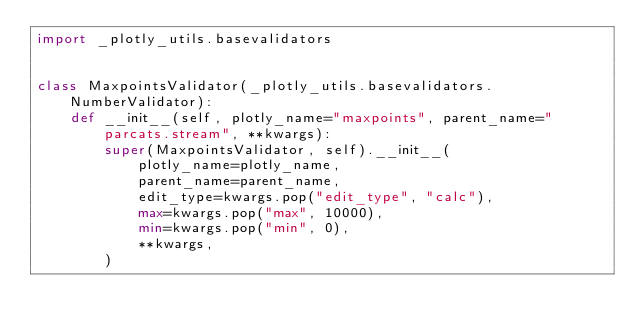Convert code to text. <code><loc_0><loc_0><loc_500><loc_500><_Python_>import _plotly_utils.basevalidators


class MaxpointsValidator(_plotly_utils.basevalidators.NumberValidator):
    def __init__(self, plotly_name="maxpoints", parent_name="parcats.stream", **kwargs):
        super(MaxpointsValidator, self).__init__(
            plotly_name=plotly_name,
            parent_name=parent_name,
            edit_type=kwargs.pop("edit_type", "calc"),
            max=kwargs.pop("max", 10000),
            min=kwargs.pop("min", 0),
            **kwargs,
        )
</code> 